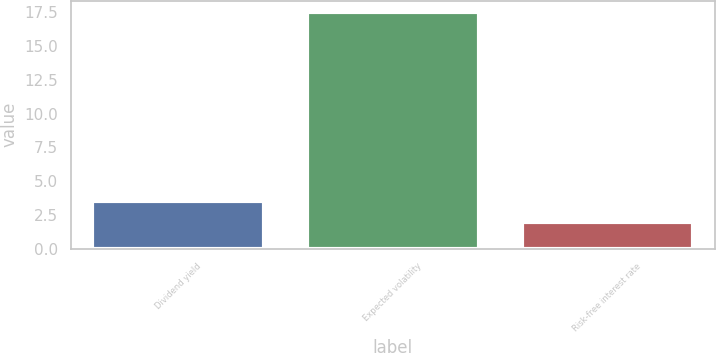Convert chart. <chart><loc_0><loc_0><loc_500><loc_500><bar_chart><fcel>Dividend yield<fcel>Expected volatility<fcel>Risk-free interest rate<nl><fcel>3.55<fcel>17.5<fcel>2<nl></chart> 